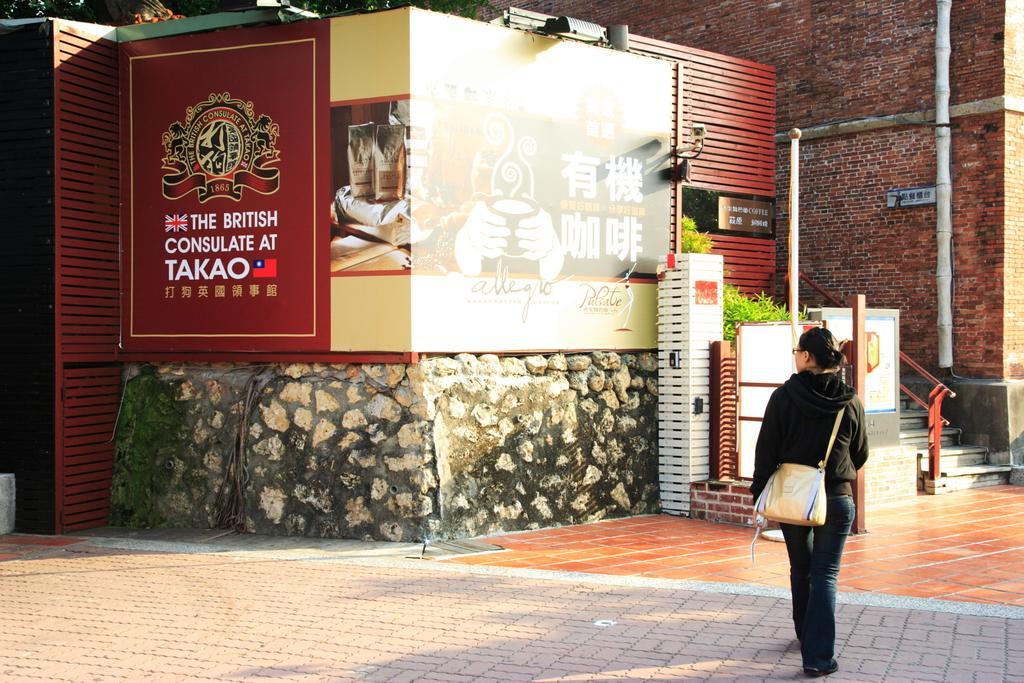Describe this image in one or two sentences. In this image there is a person wearing a bag, there are staircase, there is a wall truncated towards the top of the image, there are poles, there are boards, there is text on the board, there are plants, there are objects truncated towards the top of the image, there is an object truncated towards the left of the image. 